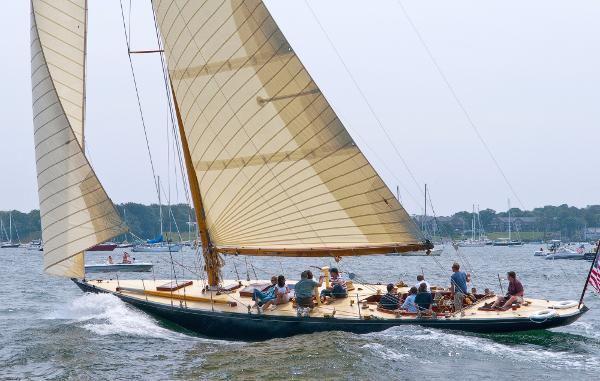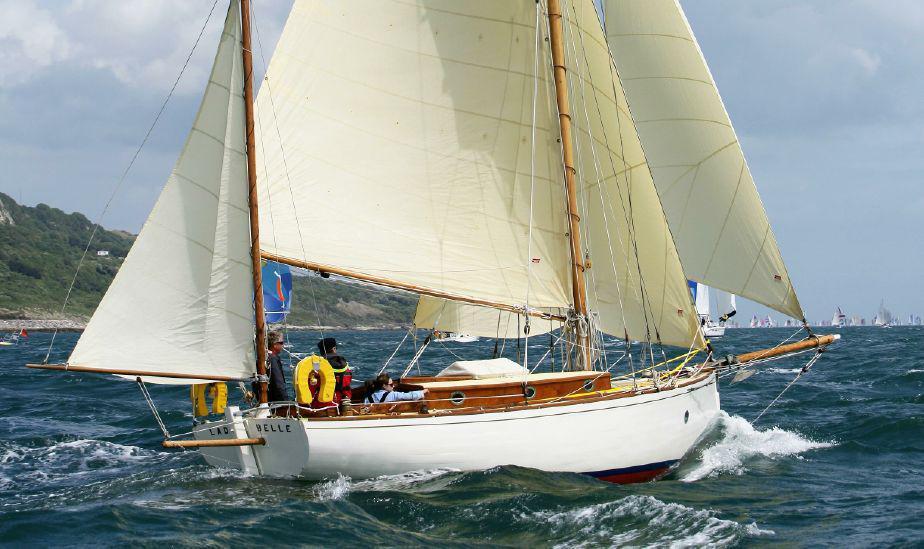The first image is the image on the left, the second image is the image on the right. Considering the images on both sides, is "An image shows a sailboat with a blue body creating white spray as it moves across the water." valid? Answer yes or no. Yes. 